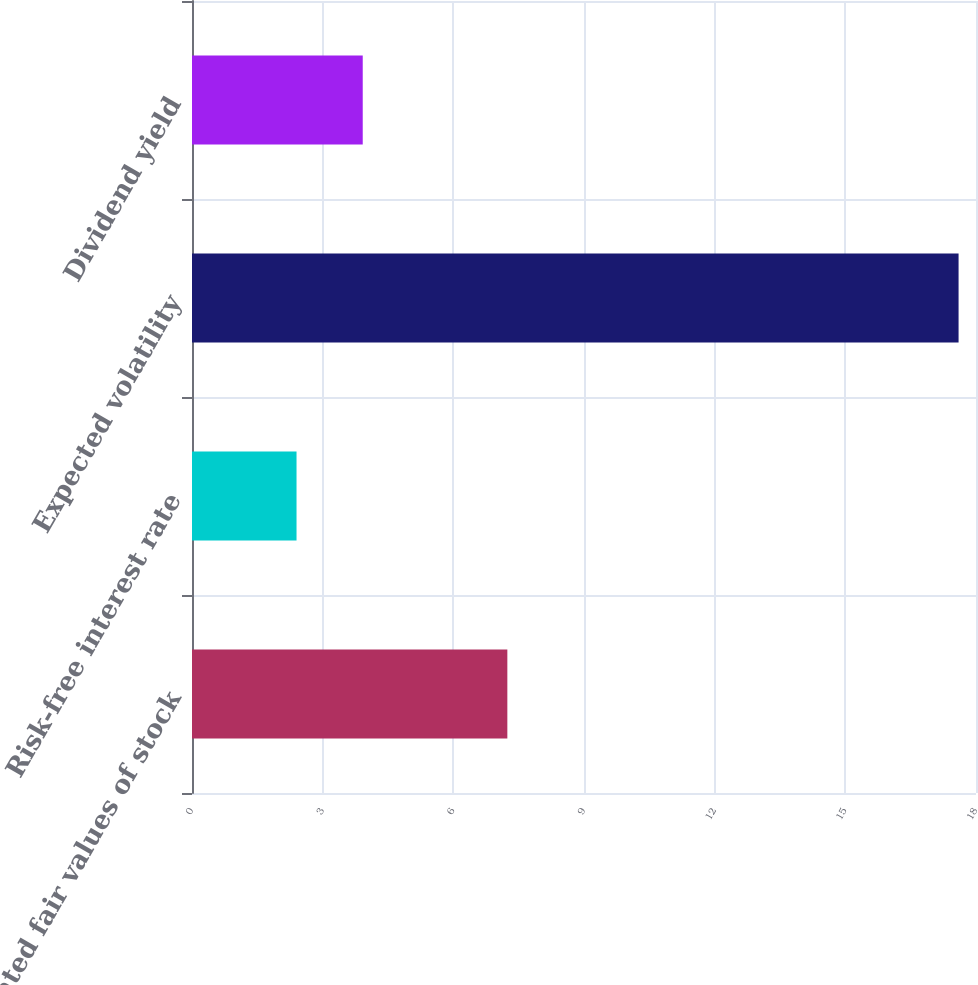<chart> <loc_0><loc_0><loc_500><loc_500><bar_chart><fcel>Estimated fair values of stock<fcel>Risk-free interest rate<fcel>Expected volatility<fcel>Dividend yield<nl><fcel>7.24<fcel>2.4<fcel>17.6<fcel>3.92<nl></chart> 